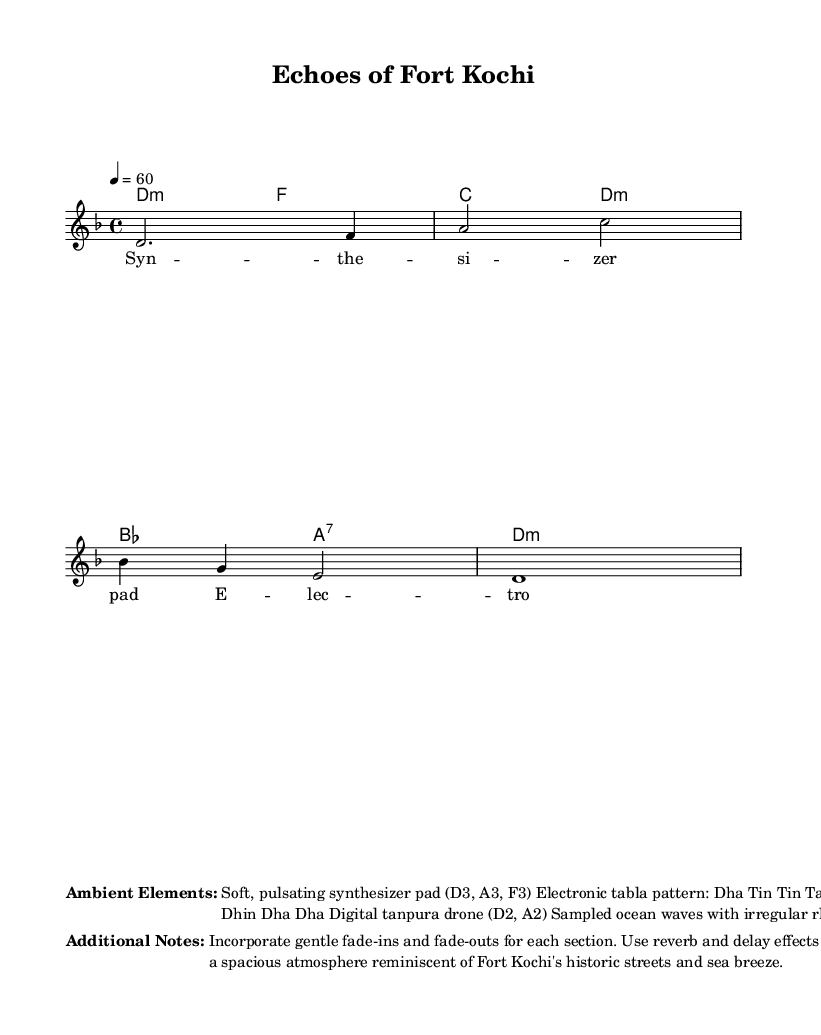What is the key signature of this music? The key signature is indicated by the placement of the note specifically before the clef. In this case, it shows one flat, which signifies that the key is D minor.
Answer: D minor What is the time signature of this music? The time signature is located at the beginning of the staff and is represented by the numbers 4 and 4. This means there are four beats in each measure and a quarter note receives one beat.
Answer: 4/4 What is the tempo marking for this piece? The tempo marking is found close to the beginning of the score and indicates the speed of the music. The number 60 corresponds to beats per minute, dictating that there should be sixty quarter note beats in one minute.
Answer: 60 How many measures are in the melody? By examining the melody section, we can count the distinct segments separated by vertical lines (bar lines). There are four measures present in this melody.
Answer: 4 What elements create the ambient soundscape? The ambient soundscape is described in the markup sections beneath the music. It lists several components, including a synthesizer pad, electronic tabla pattern, tanpura drone, and sampled ocean waves, which together enhance the atmospheric quality.
Answer: Synthesizer pad, electronic tabla pattern, tanpura drone, sampled ocean waves How is the atmosphere enhanced in this piece? According to the additional notes provided in the markup, the atmosphere is enhanced through the use of gentle fade-ins and fade-outs between sections, as well as applying reverb and delay effects. This technique creates a more spacious and immersive sound reminiscent of Fort Kochi.
Answer: Reverb and delay effects 